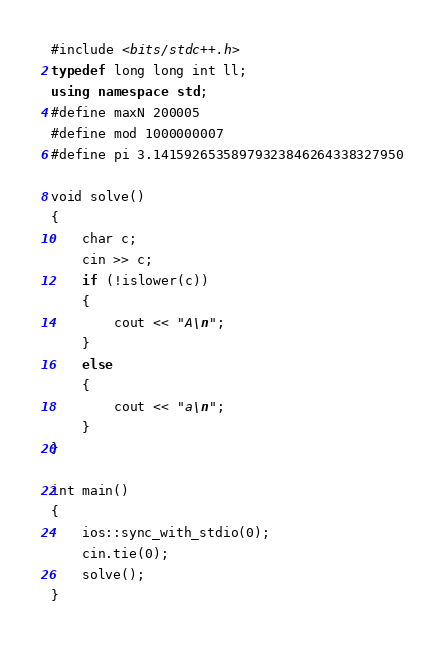<code> <loc_0><loc_0><loc_500><loc_500><_C++_>#include <bits/stdc++.h>
typedef long long int ll;
using namespace std;
#define maxN 200005
#define mod 1000000007
#define pi 3.14159265358979323846264338327950

void solve()
{
    char c;
    cin >> c;
    if (!islower(c))
    {
        cout << "A\n";
    }
    else
    {
        cout << "a\n";
    }
}

int main()
{
    ios::sync_with_stdio(0);
    cin.tie(0);
    solve();
}</code> 